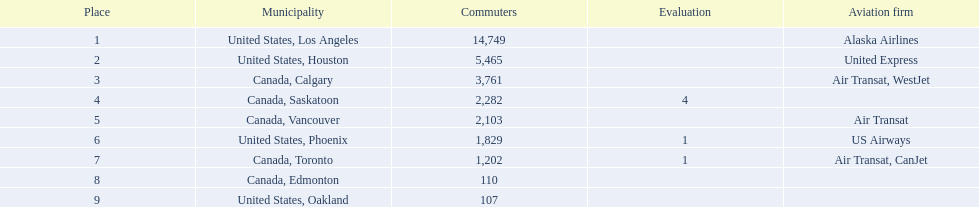Which airport has the least amount of passengers? 107. What airport has 107 passengers? United States, Oakland. 